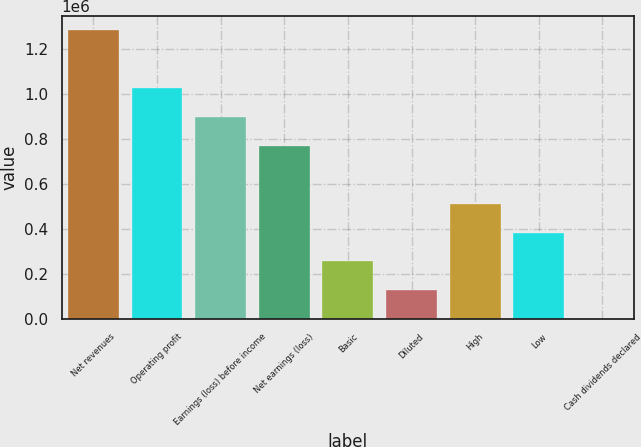Convert chart. <chart><loc_0><loc_0><loc_500><loc_500><bar_chart><fcel>Net revenues<fcel>Operating profit<fcel>Earnings (loss) before income<fcel>Net earnings (loss)<fcel>Basic<fcel>Diluted<fcel>High<fcel>Low<fcel>Cash dividends declared<nl><fcel>1.28177e+06<fcel>1.02542e+06<fcel>897241<fcel>769064<fcel>256355<fcel>128178<fcel>512709<fcel>384532<fcel>0.4<nl></chart> 